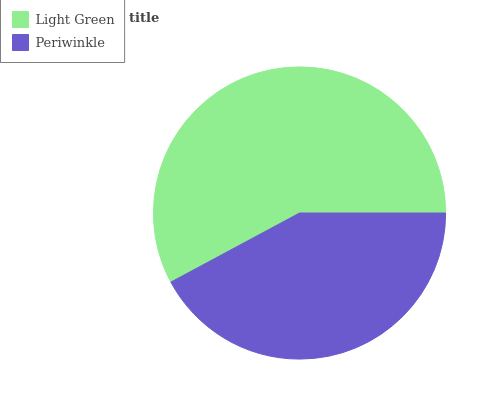Is Periwinkle the minimum?
Answer yes or no. Yes. Is Light Green the maximum?
Answer yes or no. Yes. Is Periwinkle the maximum?
Answer yes or no. No. Is Light Green greater than Periwinkle?
Answer yes or no. Yes. Is Periwinkle less than Light Green?
Answer yes or no. Yes. Is Periwinkle greater than Light Green?
Answer yes or no. No. Is Light Green less than Periwinkle?
Answer yes or no. No. Is Light Green the high median?
Answer yes or no. Yes. Is Periwinkle the low median?
Answer yes or no. Yes. Is Periwinkle the high median?
Answer yes or no. No. Is Light Green the low median?
Answer yes or no. No. 